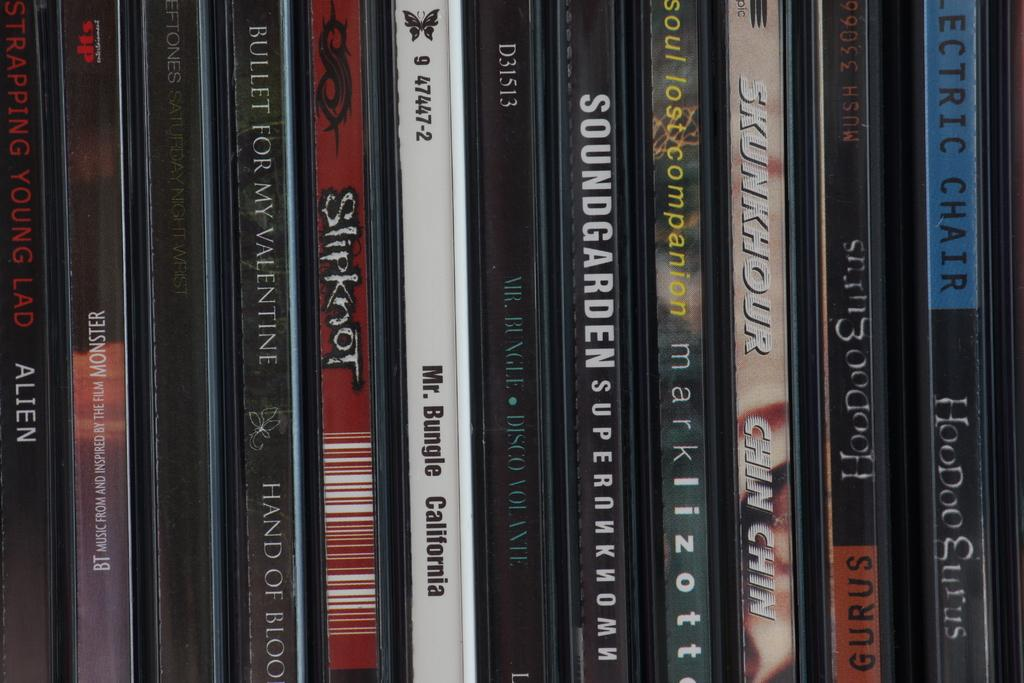<image>
Write a terse but informative summary of the picture. a Soundgarden CD is among many other ones 